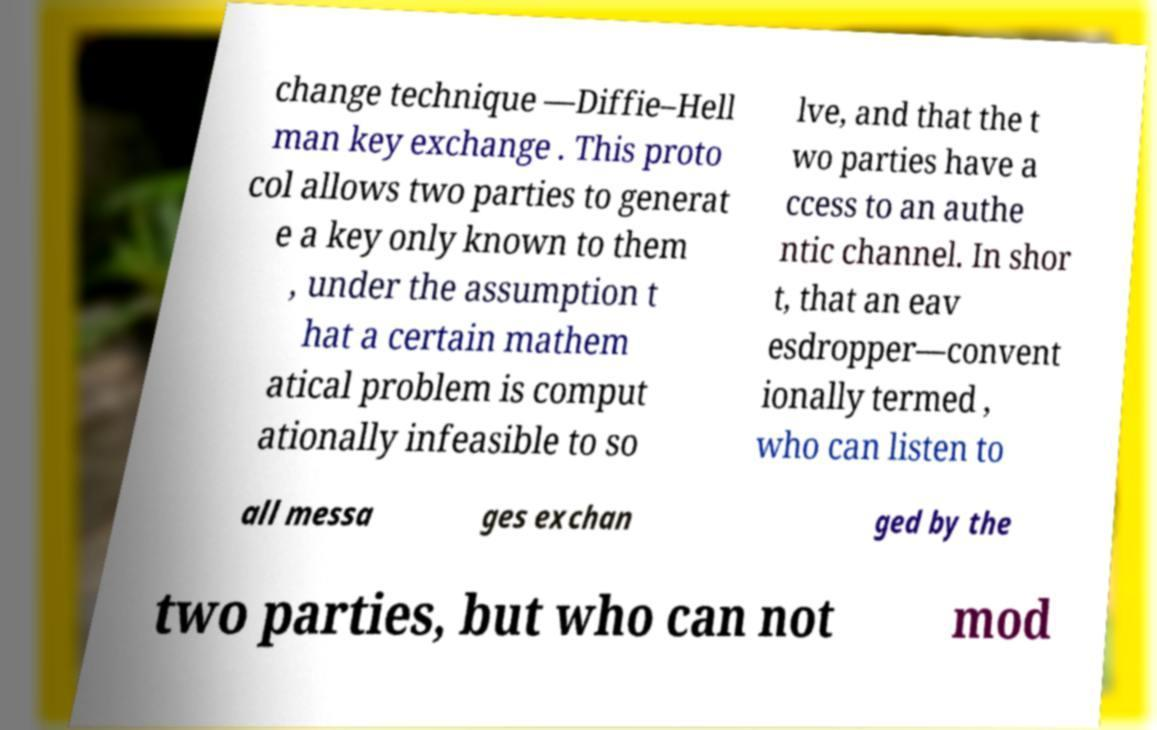For documentation purposes, I need the text within this image transcribed. Could you provide that? change technique —Diffie–Hell man key exchange . This proto col allows two parties to generat e a key only known to them , under the assumption t hat a certain mathem atical problem is comput ationally infeasible to so lve, and that the t wo parties have a ccess to an authe ntic channel. In shor t, that an eav esdropper—convent ionally termed , who can listen to all messa ges exchan ged by the two parties, but who can not mod 